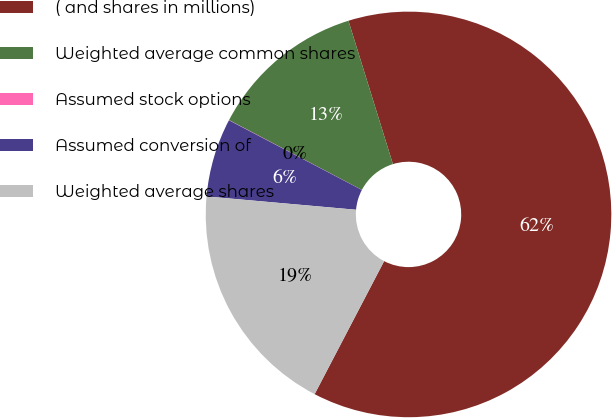Convert chart to OTSL. <chart><loc_0><loc_0><loc_500><loc_500><pie_chart><fcel>( and shares in millions)<fcel>Weighted average common shares<fcel>Assumed stock options<fcel>Assumed conversion of<fcel>Weighted average shares<nl><fcel>62.45%<fcel>12.51%<fcel>0.02%<fcel>6.27%<fcel>18.75%<nl></chart> 